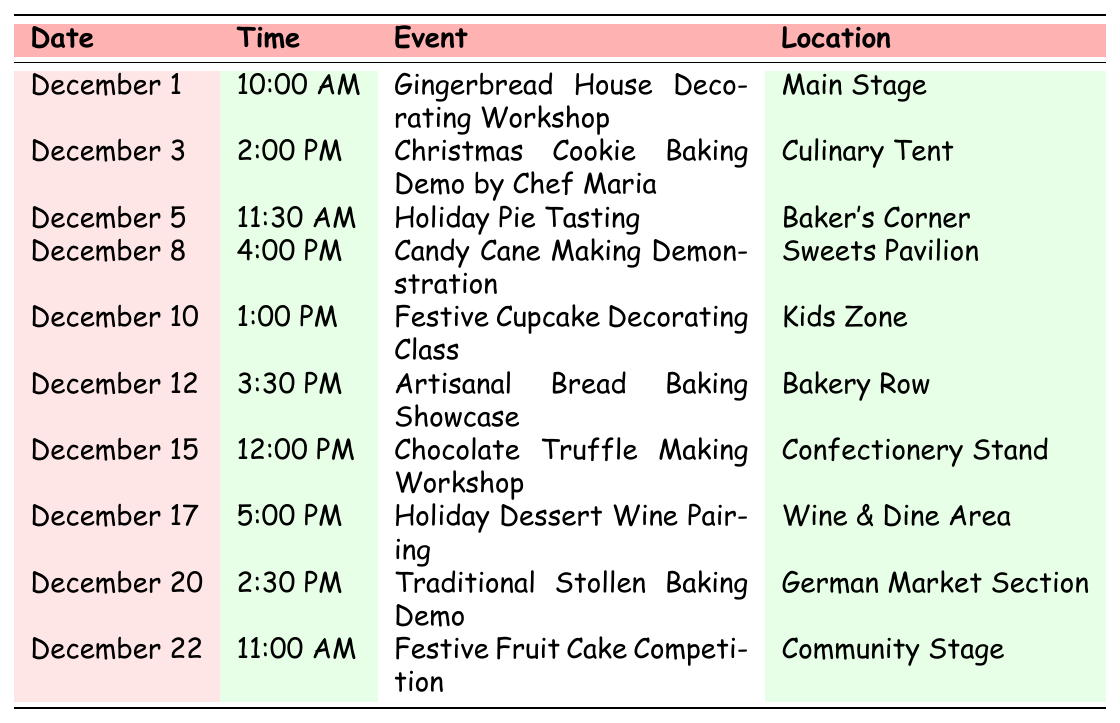What is the event occurring on December 5? The table lists the events by date, and on December 5 the event is "Holiday Pie Tasting".
Answer: Holiday Pie Tasting What time does the Candy Cane Making Demonstration start? The event for the Candy Cane Making Demonstration is scheduled for December 8, and it starts at 4:00 PM.
Answer: 4:00 PM How many events take place on December 20 or later? The events listed on December 20 are "Traditional Stollen Baking Demo" and "Festive Fruit Cake Competition" is on December 22. Therefore, there are 3 events (including December 20).
Answer: 3 Is there an event at the Culinary Tent? The table shows there is indeed an event at the Culinary Tent on December 3, which is the "Christmas Cookie Baking Demo by Chef Maria."
Answer: Yes Which event has the latest start time? The event with the latest start time is "Holiday Dessert Wine Pairing" on December 17, starting at 5:00 PM.
Answer: Holiday Dessert Wine Pairing What are the names of the events scheduled for the first half of December? The events in the first half of December are "Gingerbread House Decorating Workshop" (Dec 1), "Christmas Cookie Baking Demo by Chef Maria" (Dec 3), "Holiday Pie Tasting" (Dec 5), and "Candy Cane Making Demonstration" (Dec 8).
Answer: Gingerbread House Decorating Workshop, Christmas Cookie Baking Demo by Chef Maria, Holiday Pie Tasting, Candy Cane Making Demonstration What is the event scheduled closest to Christmas? The event closest to Christmas is the "Festive Fruit Cake Competition" on December 22.
Answer: Festive Fruit Cake Competition How many baking demonstrations are featured in the schedule? The schedule features 5 baking demonstrations: "Christmas Cookie Baking Demo" (Dec 3), "Holiday Pie Tasting" (Dec 5), "Candy Cane Making Demonstration" (Dec 8), "Artisanal Bread Baking Showcase" (Dec 12), and "Traditional Stollen Baking Demo" (Dec 20).
Answer: 5 When does the Festive Cupcake Decorating Class take place? The event "Festive Cupcake Decorating Class" is scheduled for December 10 at 1:00 PM.
Answer: December 10 at 1:00 PM 